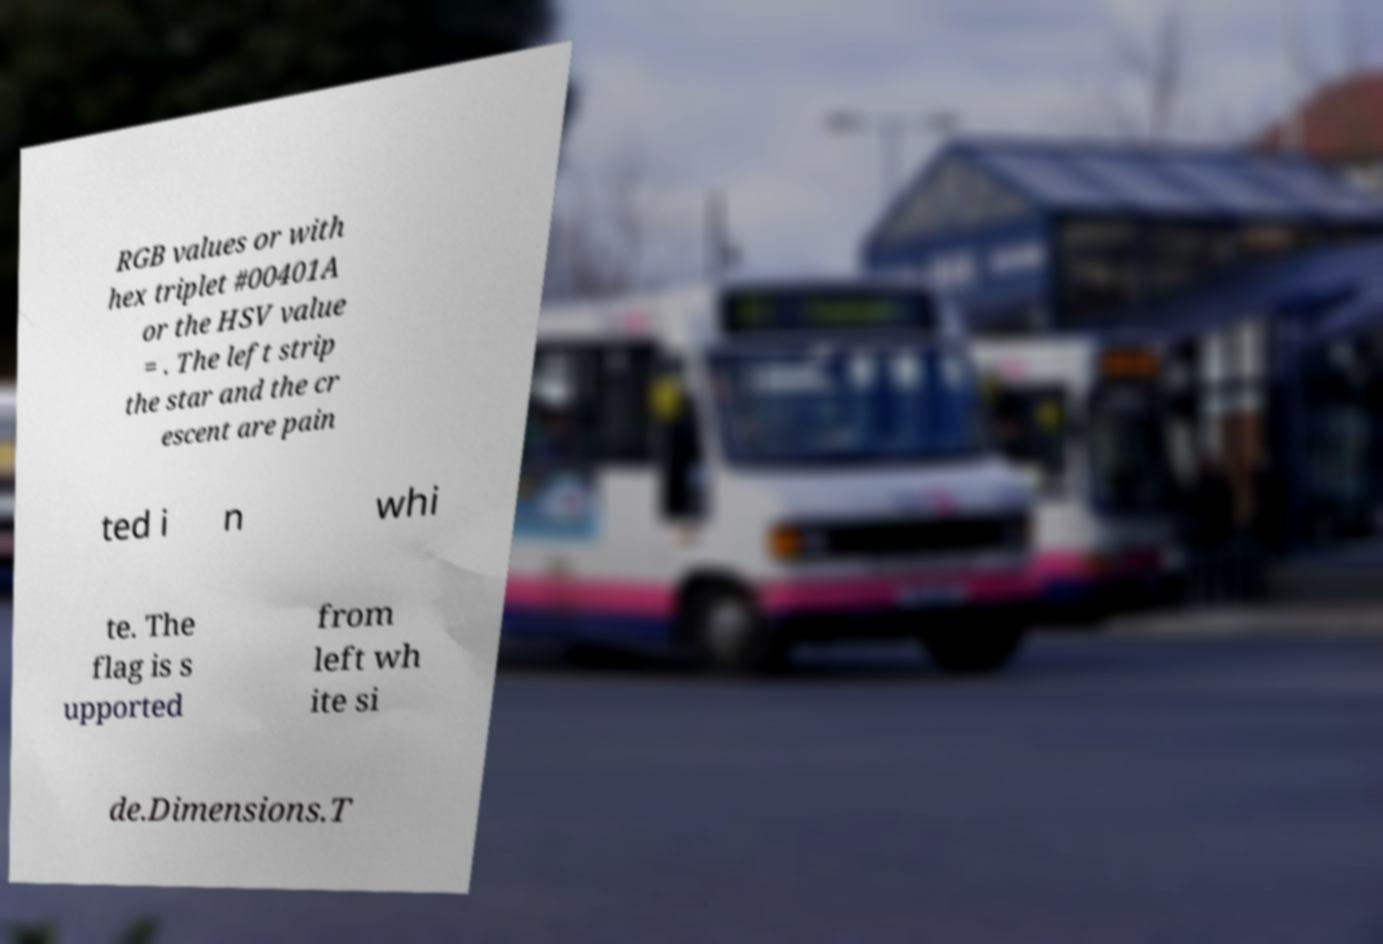Please read and relay the text visible in this image. What does it say? RGB values or with hex triplet #00401A or the HSV value = . The left strip the star and the cr escent are pain ted i n whi te. The flag is s upported from left wh ite si de.Dimensions.T 